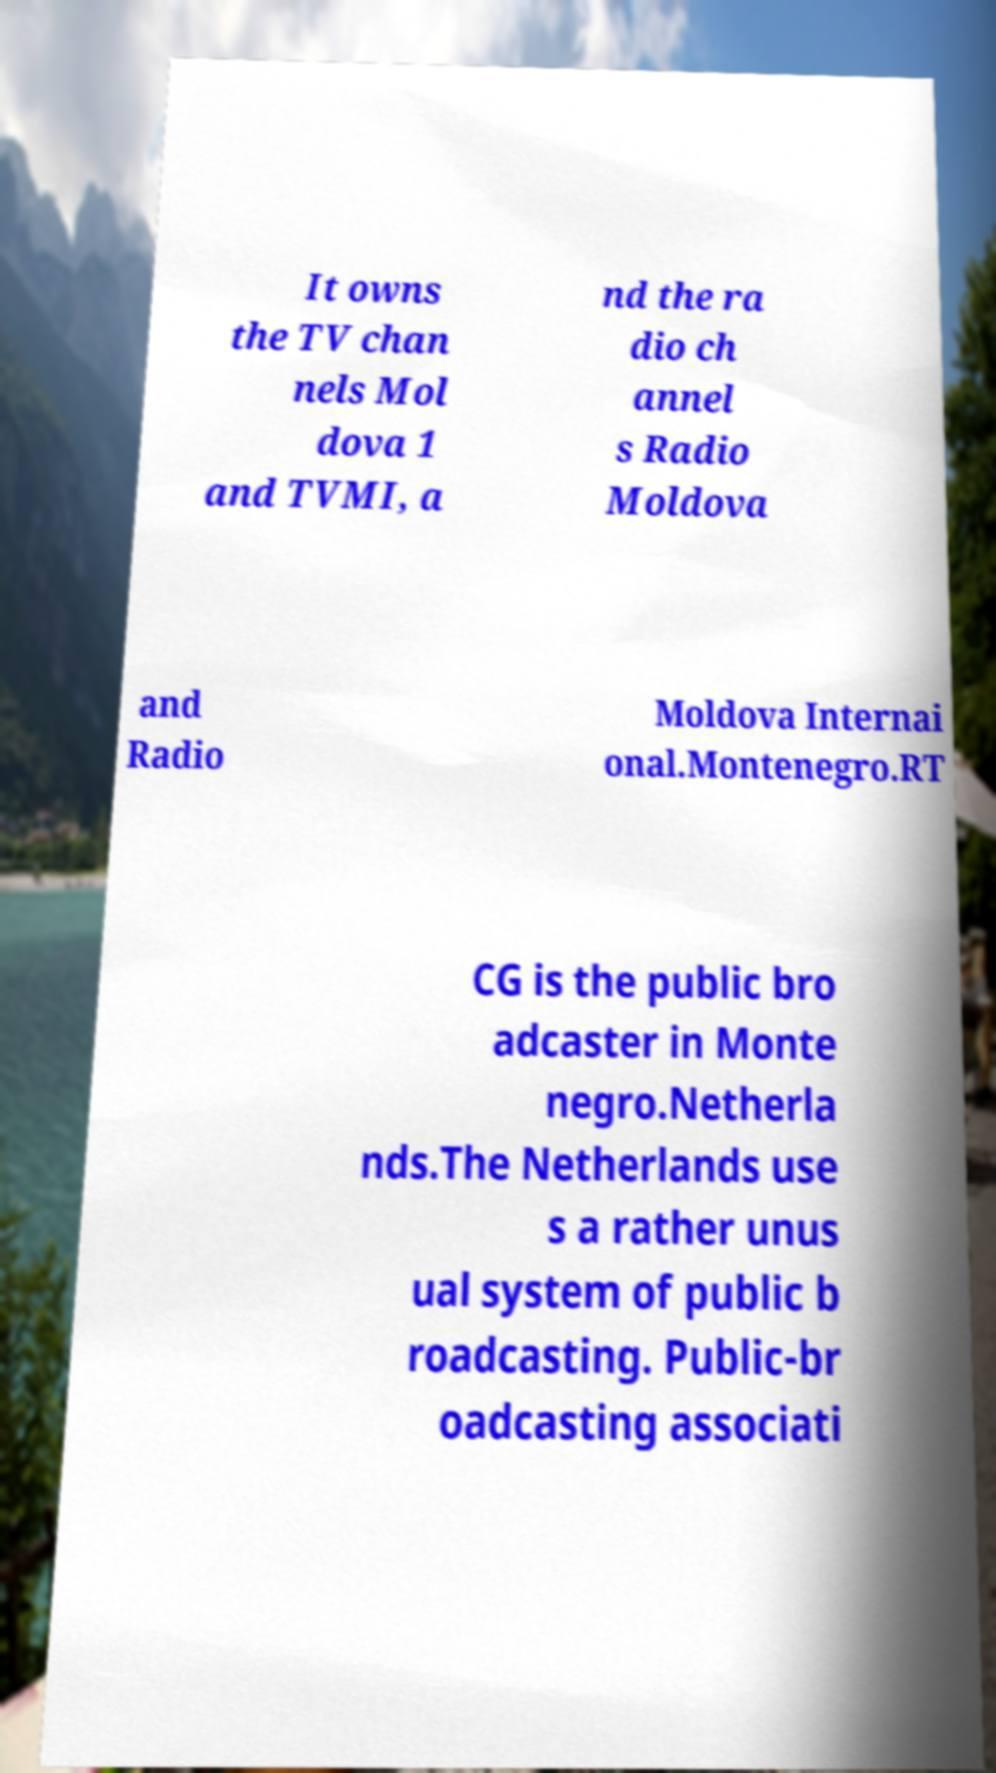What messages or text are displayed in this image? I need them in a readable, typed format. It owns the TV chan nels Mol dova 1 and TVMI, a nd the ra dio ch annel s Radio Moldova and Radio Moldova Internai onal.Montenegro.RT CG is the public bro adcaster in Monte negro.Netherla nds.The Netherlands use s a rather unus ual system of public b roadcasting. Public-br oadcasting associati 